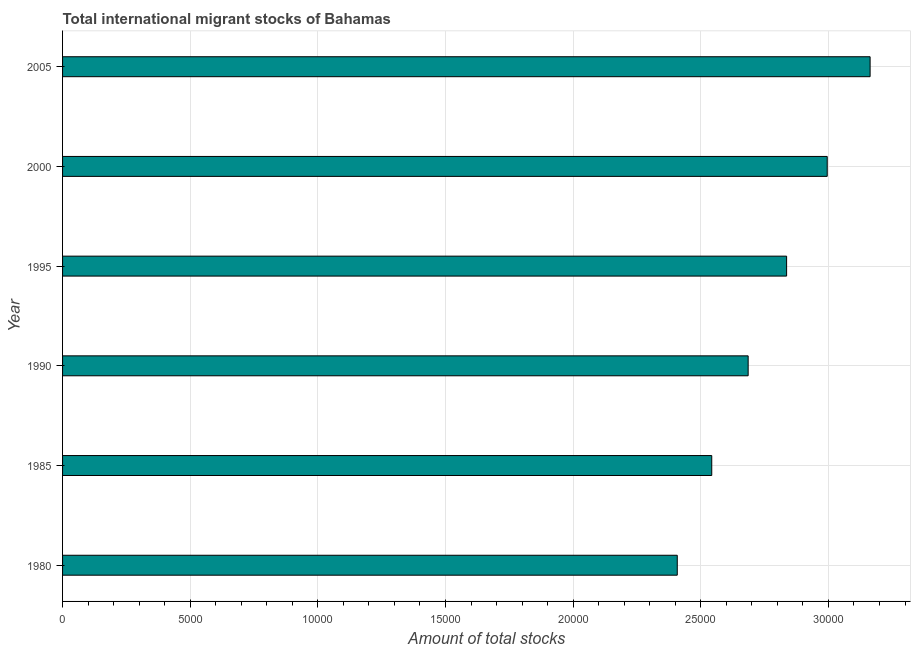Does the graph contain grids?
Offer a terse response. Yes. What is the title of the graph?
Provide a short and direct response. Total international migrant stocks of Bahamas. What is the label or title of the X-axis?
Offer a terse response. Amount of total stocks. What is the label or title of the Y-axis?
Provide a short and direct response. Year. What is the total number of international migrant stock in 1980?
Offer a terse response. 2.41e+04. Across all years, what is the maximum total number of international migrant stock?
Keep it short and to the point. 3.16e+04. Across all years, what is the minimum total number of international migrant stock?
Provide a short and direct response. 2.41e+04. In which year was the total number of international migrant stock maximum?
Your answer should be compact. 2005. What is the sum of the total number of international migrant stock?
Ensure brevity in your answer.  1.66e+05. What is the difference between the total number of international migrant stock in 1980 and 2000?
Offer a terse response. -5874. What is the average total number of international migrant stock per year?
Offer a very short reply. 2.77e+04. What is the median total number of international migrant stock?
Ensure brevity in your answer.  2.76e+04. In how many years, is the total number of international migrant stock greater than 15000 ?
Your answer should be very brief. 6. What is the ratio of the total number of international migrant stock in 1980 to that in 2000?
Your answer should be very brief. 0.8. What is the difference between the highest and the second highest total number of international migrant stock?
Provide a succinct answer. 1680. Is the sum of the total number of international migrant stock in 1995 and 2000 greater than the maximum total number of international migrant stock across all years?
Provide a succinct answer. Yes. What is the difference between the highest and the lowest total number of international migrant stock?
Provide a succinct answer. 7554. In how many years, is the total number of international migrant stock greater than the average total number of international migrant stock taken over all years?
Offer a terse response. 3. How many bars are there?
Your answer should be compact. 6. What is the Amount of total stocks of 1980?
Offer a very short reply. 2.41e+04. What is the Amount of total stocks of 1985?
Your response must be concise. 2.54e+04. What is the Amount of total stocks in 1990?
Your answer should be compact. 2.69e+04. What is the Amount of total stocks in 1995?
Offer a very short reply. 2.84e+04. What is the Amount of total stocks of 2000?
Your response must be concise. 3.00e+04. What is the Amount of total stocks of 2005?
Give a very brief answer. 3.16e+04. What is the difference between the Amount of total stocks in 1980 and 1985?
Offer a terse response. -1351. What is the difference between the Amount of total stocks in 1980 and 1990?
Give a very brief answer. -2777. What is the difference between the Amount of total stocks in 1980 and 1995?
Offer a terse response. -4283. What is the difference between the Amount of total stocks in 1980 and 2000?
Give a very brief answer. -5874. What is the difference between the Amount of total stocks in 1980 and 2005?
Your response must be concise. -7554. What is the difference between the Amount of total stocks in 1985 and 1990?
Provide a succinct answer. -1426. What is the difference between the Amount of total stocks in 1985 and 1995?
Your response must be concise. -2932. What is the difference between the Amount of total stocks in 1985 and 2000?
Provide a short and direct response. -4523. What is the difference between the Amount of total stocks in 1985 and 2005?
Make the answer very short. -6203. What is the difference between the Amount of total stocks in 1990 and 1995?
Give a very brief answer. -1506. What is the difference between the Amount of total stocks in 1990 and 2000?
Keep it short and to the point. -3097. What is the difference between the Amount of total stocks in 1990 and 2005?
Provide a succinct answer. -4777. What is the difference between the Amount of total stocks in 1995 and 2000?
Your answer should be very brief. -1591. What is the difference between the Amount of total stocks in 1995 and 2005?
Provide a succinct answer. -3271. What is the difference between the Amount of total stocks in 2000 and 2005?
Your response must be concise. -1680. What is the ratio of the Amount of total stocks in 1980 to that in 1985?
Your response must be concise. 0.95. What is the ratio of the Amount of total stocks in 1980 to that in 1990?
Provide a succinct answer. 0.9. What is the ratio of the Amount of total stocks in 1980 to that in 1995?
Give a very brief answer. 0.85. What is the ratio of the Amount of total stocks in 1980 to that in 2000?
Your response must be concise. 0.8. What is the ratio of the Amount of total stocks in 1980 to that in 2005?
Make the answer very short. 0.76. What is the ratio of the Amount of total stocks in 1985 to that in 1990?
Ensure brevity in your answer.  0.95. What is the ratio of the Amount of total stocks in 1985 to that in 1995?
Offer a terse response. 0.9. What is the ratio of the Amount of total stocks in 1985 to that in 2000?
Offer a terse response. 0.85. What is the ratio of the Amount of total stocks in 1985 to that in 2005?
Provide a succinct answer. 0.8. What is the ratio of the Amount of total stocks in 1990 to that in 1995?
Your answer should be very brief. 0.95. What is the ratio of the Amount of total stocks in 1990 to that in 2000?
Your response must be concise. 0.9. What is the ratio of the Amount of total stocks in 1990 to that in 2005?
Ensure brevity in your answer.  0.85. What is the ratio of the Amount of total stocks in 1995 to that in 2000?
Keep it short and to the point. 0.95. What is the ratio of the Amount of total stocks in 1995 to that in 2005?
Offer a terse response. 0.9. What is the ratio of the Amount of total stocks in 2000 to that in 2005?
Your answer should be very brief. 0.95. 